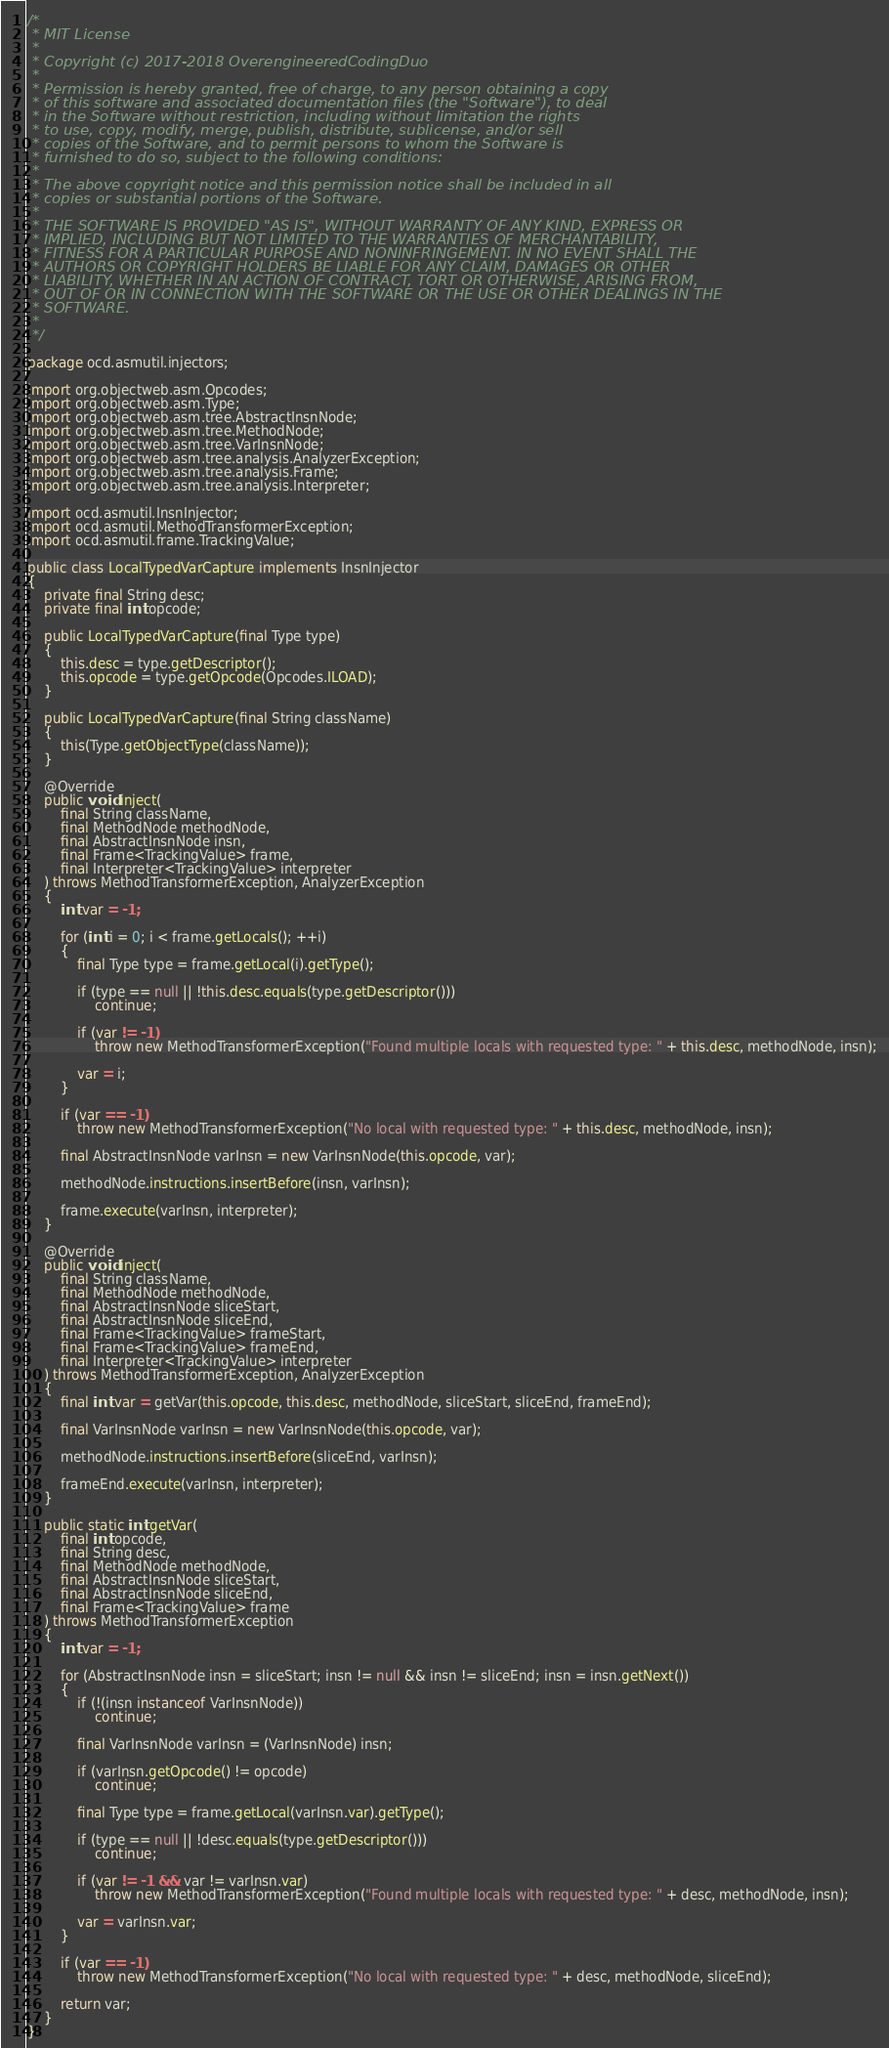<code> <loc_0><loc_0><loc_500><loc_500><_Java_>/*
 * MIT License
 *
 * Copyright (c) 2017-2018 OverengineeredCodingDuo
 *
 * Permission is hereby granted, free of charge, to any person obtaining a copy
 * of this software and associated documentation files (the "Software"), to deal
 * in the Software without restriction, including without limitation the rights
 * to use, copy, modify, merge, publish, distribute, sublicense, and/or sell
 * copies of the Software, and to permit persons to whom the Software is
 * furnished to do so, subject to the following conditions:
 *
 * The above copyright notice and this permission notice shall be included in all
 * copies or substantial portions of the Software.
 *
 * THE SOFTWARE IS PROVIDED "AS IS", WITHOUT WARRANTY OF ANY KIND, EXPRESS OR
 * IMPLIED, INCLUDING BUT NOT LIMITED TO THE WARRANTIES OF MERCHANTABILITY,
 * FITNESS FOR A PARTICULAR PURPOSE AND NONINFRINGEMENT. IN NO EVENT SHALL THE
 * AUTHORS OR COPYRIGHT HOLDERS BE LIABLE FOR ANY CLAIM, DAMAGES OR OTHER
 * LIABILITY, WHETHER IN AN ACTION OF CONTRACT, TORT OR OTHERWISE, ARISING FROM,
 * OUT OF OR IN CONNECTION WITH THE SOFTWARE OR THE USE OR OTHER DEALINGS IN THE
 * SOFTWARE.
 *
 */

package ocd.asmutil.injectors;

import org.objectweb.asm.Opcodes;
import org.objectweb.asm.Type;
import org.objectweb.asm.tree.AbstractInsnNode;
import org.objectweb.asm.tree.MethodNode;
import org.objectweb.asm.tree.VarInsnNode;
import org.objectweb.asm.tree.analysis.AnalyzerException;
import org.objectweb.asm.tree.analysis.Frame;
import org.objectweb.asm.tree.analysis.Interpreter;

import ocd.asmutil.InsnInjector;
import ocd.asmutil.MethodTransformerException;
import ocd.asmutil.frame.TrackingValue;

public class LocalTypedVarCapture implements InsnInjector
{
	private final String desc;
	private final int opcode;

	public LocalTypedVarCapture(final Type type)
	{
		this.desc = type.getDescriptor();
		this.opcode = type.getOpcode(Opcodes.ILOAD);
	}

	public LocalTypedVarCapture(final String className)
	{
		this(Type.getObjectType(className));
	}

	@Override
	public void inject(
		final String className,
		final MethodNode methodNode,
		final AbstractInsnNode insn,
		final Frame<TrackingValue> frame,
		final Interpreter<TrackingValue> interpreter
	) throws MethodTransformerException, AnalyzerException
	{
		int var = -1;

		for (int i = 0; i < frame.getLocals(); ++i)
		{
			final Type type = frame.getLocal(i).getType();

			if (type == null || !this.desc.equals(type.getDescriptor()))
				continue;

			if (var != -1)
				throw new MethodTransformerException("Found multiple locals with requested type: " + this.desc, methodNode, insn);

			var = i;
		}

		if (var == -1)
			throw new MethodTransformerException("No local with requested type: " + this.desc, methodNode, insn);

		final AbstractInsnNode varInsn = new VarInsnNode(this.opcode, var);

		methodNode.instructions.insertBefore(insn, varInsn);

		frame.execute(varInsn, interpreter);
	}

	@Override
	public void inject(
		final String className,
		final MethodNode methodNode,
		final AbstractInsnNode sliceStart,
		final AbstractInsnNode sliceEnd,
		final Frame<TrackingValue> frameStart,
		final Frame<TrackingValue> frameEnd,
		final Interpreter<TrackingValue> interpreter
	) throws MethodTransformerException, AnalyzerException
	{
		final int var = getVar(this.opcode, this.desc, methodNode, sliceStart, sliceEnd, frameEnd);

		final VarInsnNode varInsn = new VarInsnNode(this.opcode, var);

		methodNode.instructions.insertBefore(sliceEnd, varInsn);

		frameEnd.execute(varInsn, interpreter);
	}

	public static int getVar(
		final int opcode,
		final String desc,
		final MethodNode methodNode,
		final AbstractInsnNode sliceStart,
		final AbstractInsnNode sliceEnd,
		final Frame<TrackingValue> frame
	) throws MethodTransformerException
	{
		int var = -1;

		for (AbstractInsnNode insn = sliceStart; insn != null && insn != sliceEnd; insn = insn.getNext())
		{
			if (!(insn instanceof VarInsnNode))
				continue;

			final VarInsnNode varInsn = (VarInsnNode) insn;

			if (varInsn.getOpcode() != opcode)
				continue;

			final Type type = frame.getLocal(varInsn.var).getType();

			if (type == null || !desc.equals(type.getDescriptor()))
				continue;

			if (var != -1 && var != varInsn.var)
				throw new MethodTransformerException("Found multiple locals with requested type: " + desc, methodNode, insn);

			var = varInsn.var;
		}

		if (var == -1)
			throw new MethodTransformerException("No local with requested type: " + desc, methodNode, sliceEnd);

		return var;
	}
}
</code> 